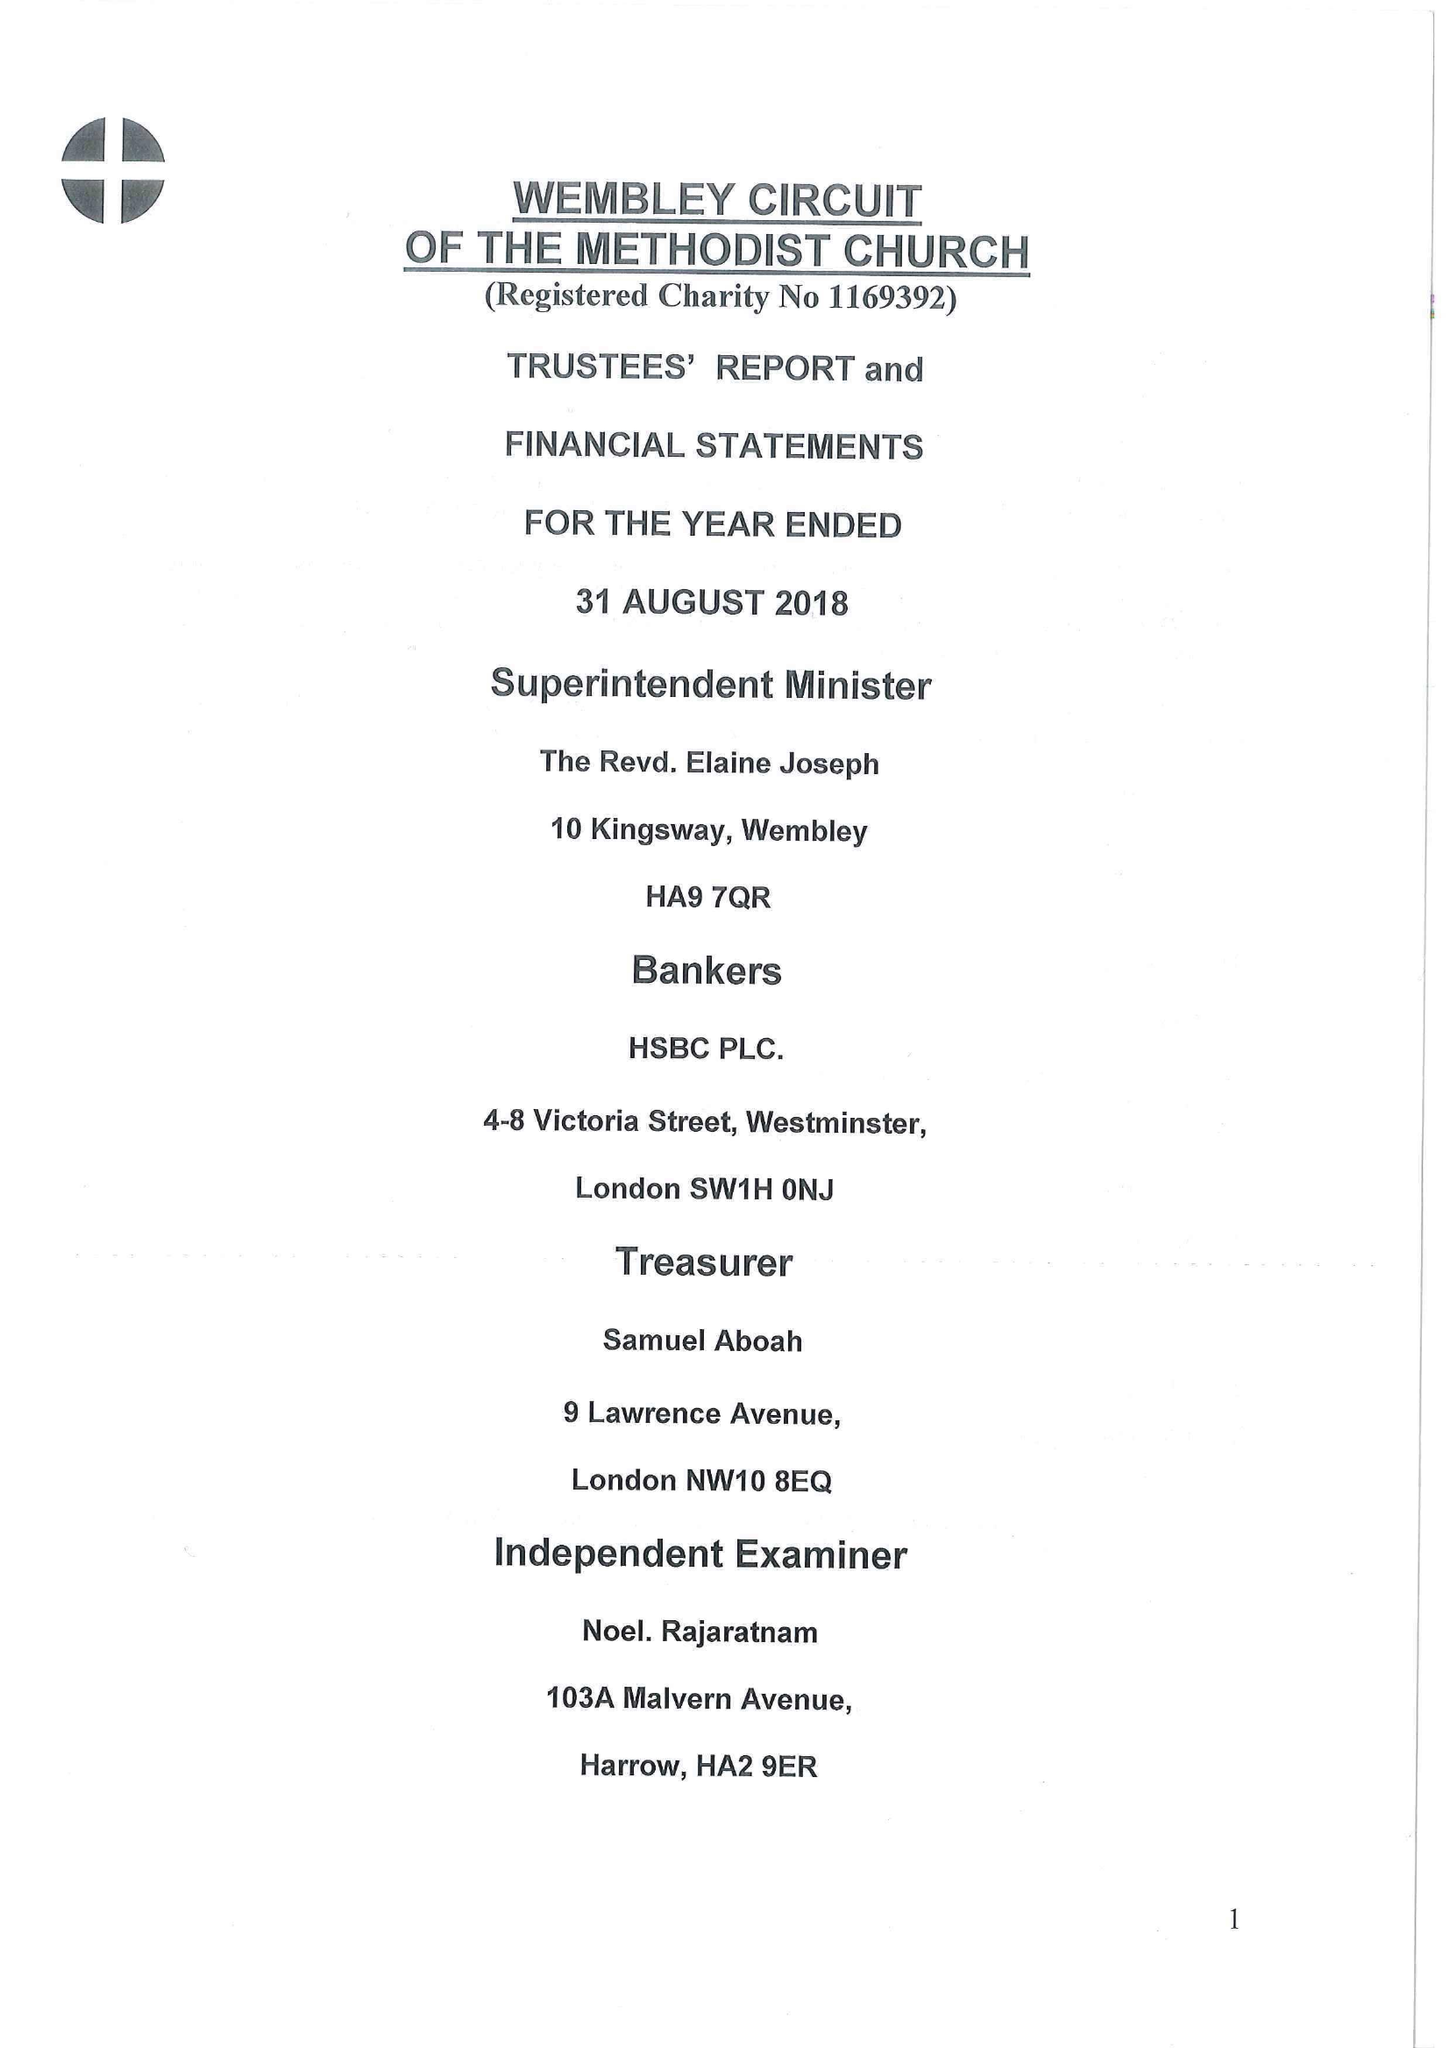What is the value for the charity_number?
Answer the question using a single word or phrase. 1169392 